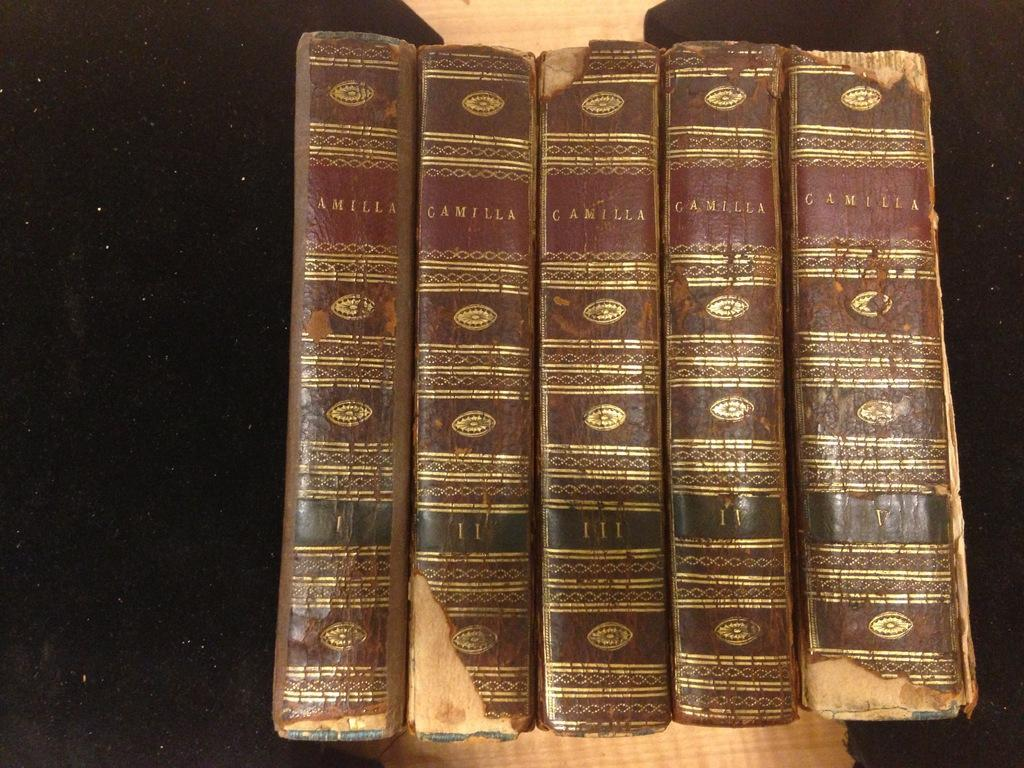<image>
Summarize the visual content of the image. A series of old Camilla books are placed next to each other. 